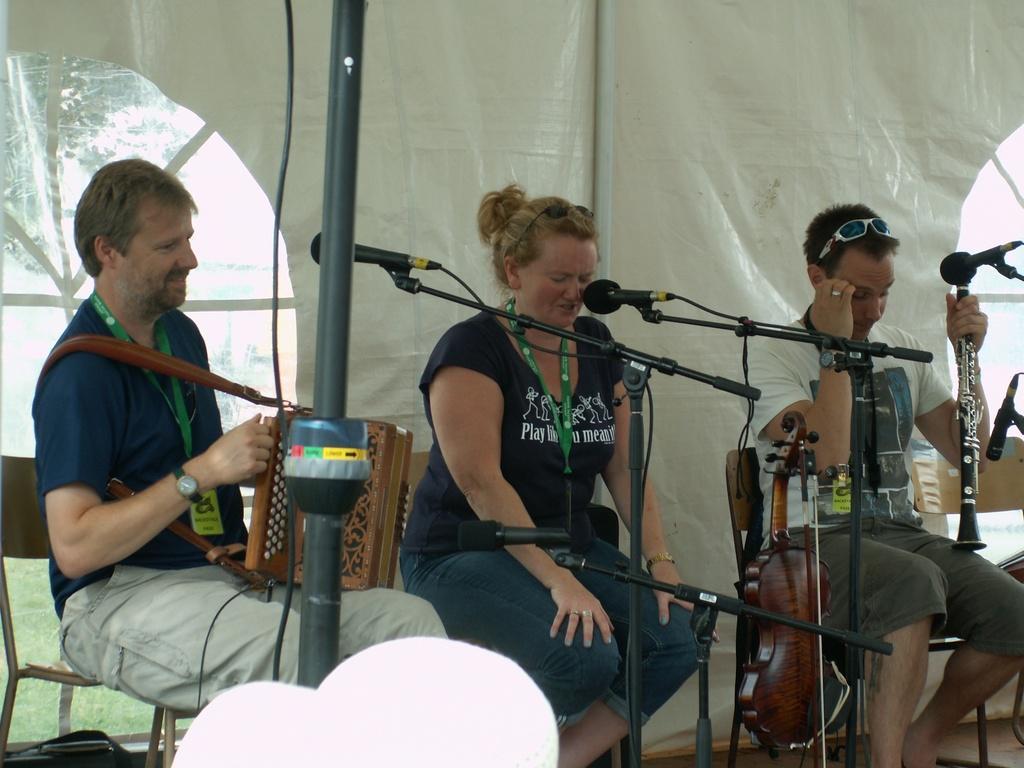How would you summarize this image in a sentence or two? In this image, we can see three people sitting on the chairs and a person on the left side and a person on the right side holding some musical instruments and in the foreground we can see the pole and some mike's. 